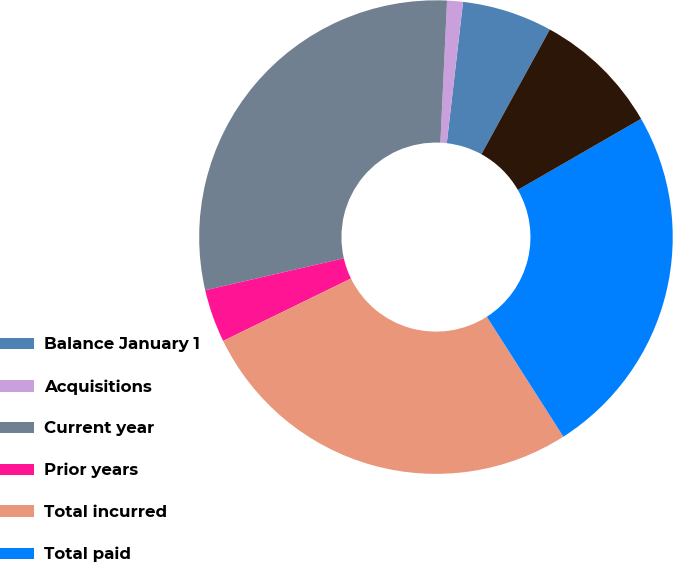<chart> <loc_0><loc_0><loc_500><loc_500><pie_chart><fcel>Balance January 1<fcel>Acquisitions<fcel>Current year<fcel>Prior years<fcel>Total incurred<fcel>Total paid<fcel>Balance December 31<nl><fcel>6.16%<fcel>1.08%<fcel>29.35%<fcel>3.62%<fcel>26.82%<fcel>24.28%<fcel>8.69%<nl></chart> 